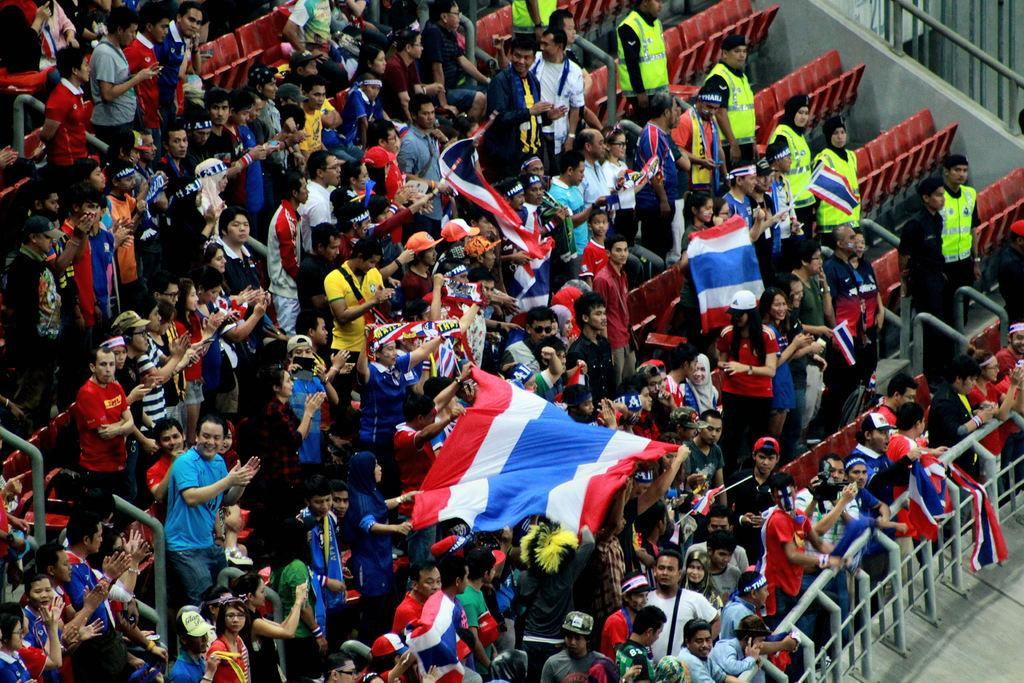How many people are in the image? There is a group of people in the image. What can be seen in the image besides the people? There are flags, seats, and some objects visible in the image. What is the ground like in the image? The ground is visible in the image. What type of pot is being used to wash the person in the image? There is no pot or washing activity present in the image. 